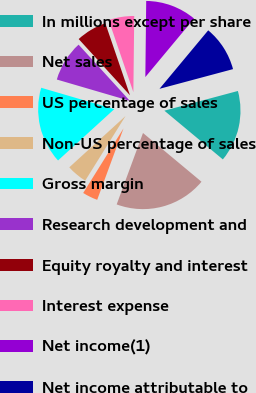Convert chart to OTSL. <chart><loc_0><loc_0><loc_500><loc_500><pie_chart><fcel>In millions except per share<fcel>Net sales<fcel>US percentage of sales<fcel>Non-US percentage of sales<fcel>Gross margin<fcel>Research development and<fcel>Equity royalty and interest<fcel>Interest expense<fcel>Net income(1)<fcel>Net income attributable to<nl><fcel>15.22%<fcel>19.56%<fcel>3.26%<fcel>4.35%<fcel>16.3%<fcel>8.7%<fcel>6.52%<fcel>5.43%<fcel>10.87%<fcel>9.78%<nl></chart> 